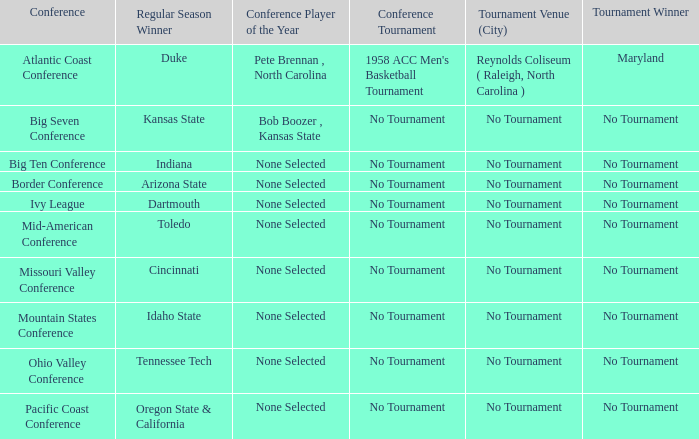Who is the tournament winner in the Atlantic Coast Conference? Maryland. 